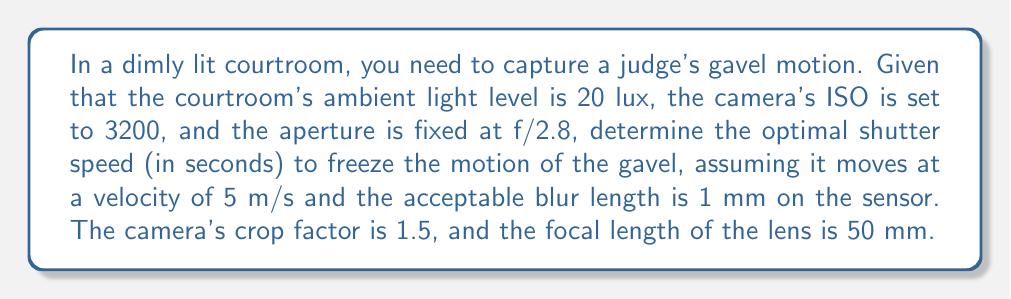Show me your answer to this math problem. To solve this problem, we'll use the following steps:

1) First, we need to calculate the field of view (FOV) on the sensor:
   FOV = (Subject Distance × Sensor Size) / Focal Length
   
   Assuming a subject distance of 3 meters:
   FOV = (3 m × 24 mm) / (50 mm × 1.5) = 0.96 m

2) Now, we calculate the magnification factor (M):
   M = Sensor Size / FOV = 24 mm / 960 mm = 1/40

3) The motion on the sensor (v_sensor) is:
   v_sensor = v_subject × M = 5 m/s × (1/40) = 0.125 m/s

4) Given the acceptable blur length (b) of 1 mm, we can calculate the shutter speed (t):
   t = b / v_sensor = 0.001 m / 0.125 m/s = 0.008 s

5) To verify if this shutter speed provides enough light, we use the Exposure Value (EV) formula:
   EV = log_2((f^2) / t) + log_2(ISO / 100)
   
   where f is the aperture (2.8), t is the shutter speed (0.008), and ISO is 3200.

   EV = log_2((2.8^2) / 0.008) + log_2(3200 / 100) ≈ 7.3

6) For 20 lux of ambient light, the required EV is approximately:
   EV = log_2(20 / 2.5) ≈ 3

7) Since our calculated EV (7.3) is higher than the required EV (3), we have enough light for this exposure.

Therefore, the optimal shutter speed of 1/125 s (0.008 s) will freeze the motion while providing sufficient exposure in the given low-light conditions.
Answer: 1/125 s 